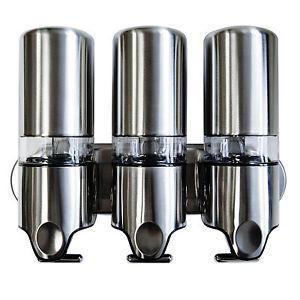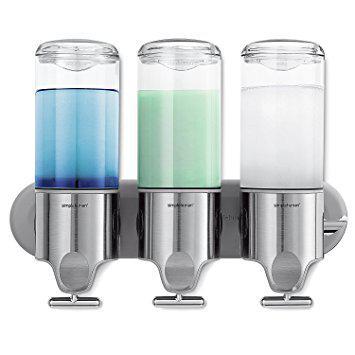The first image is the image on the left, the second image is the image on the right. Evaluate the accuracy of this statement regarding the images: "Both the top and bottom of three dispensers are made from shiny metallic material.". Is it true? Answer yes or no. Yes. 